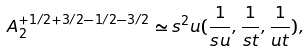<formula> <loc_0><loc_0><loc_500><loc_500>A _ { 2 } ^ { + 1 / 2 + 3 / 2 - 1 / 2 - 3 / 2 } \simeq s ^ { 2 } u ( \frac { 1 } { s u } , \frac { 1 } { s t } , \frac { 1 } { u t } ) ,</formula> 